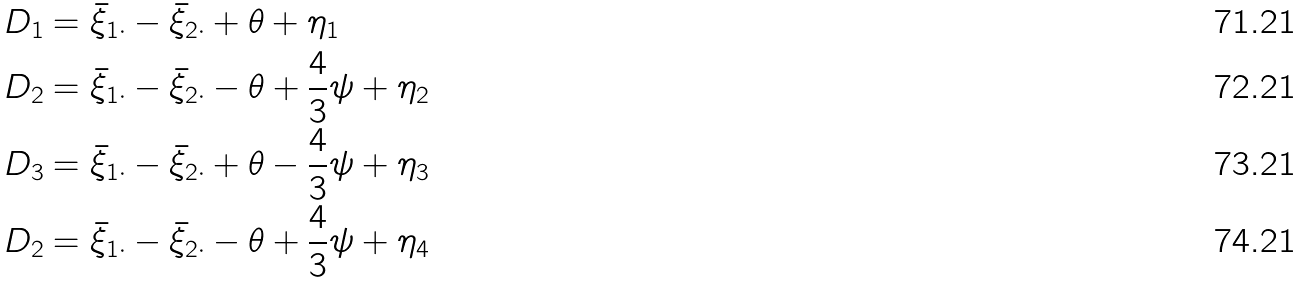Convert formula to latex. <formula><loc_0><loc_0><loc_500><loc_500>D _ { 1 } & = \bar { \xi } _ { 1 \cdot } - \bar { \xi } _ { 2 \cdot } + \theta + \eta _ { 1 } \\ D _ { 2 } & = \bar { \xi } _ { 1 \cdot } - \bar { \xi } _ { 2 \cdot } - \theta + \frac { 4 } { 3 } \psi + \eta _ { 2 } \\ D _ { 3 } & = \bar { \xi } _ { 1 \cdot } - \bar { \xi } _ { 2 \cdot } + \theta - \frac { 4 } { 3 } \psi + \eta _ { 3 } \\ D _ { 2 } & = \bar { \xi } _ { 1 \cdot } - \bar { \xi } _ { 2 \cdot } - \theta + \frac { 4 } { 3 } \psi + \eta _ { 4 }</formula> 